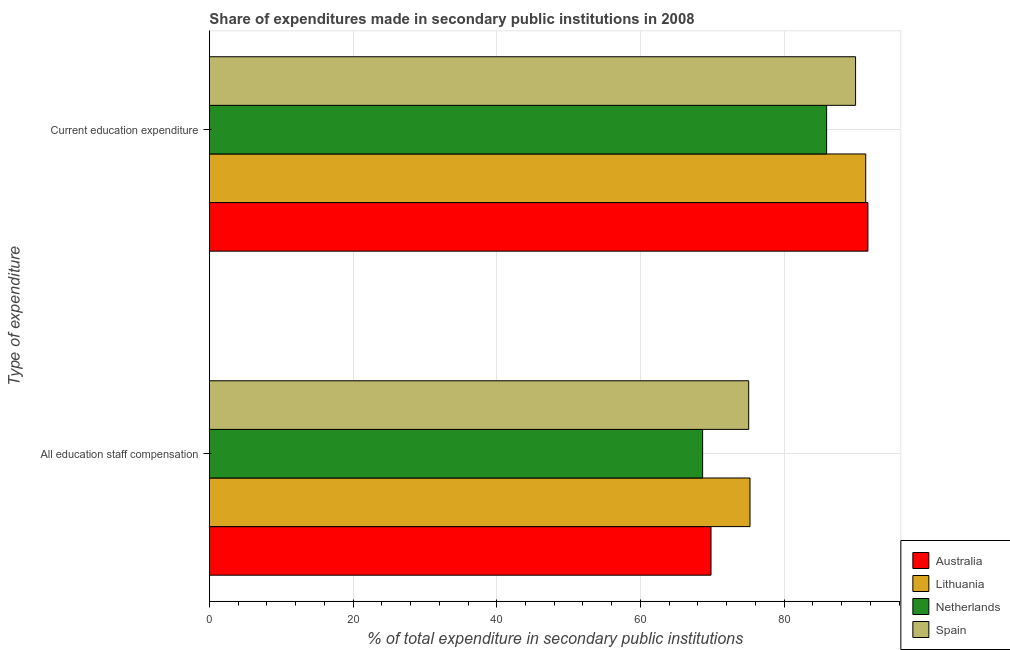Are the number of bars per tick equal to the number of legend labels?
Your answer should be very brief. Yes. How many bars are there on the 2nd tick from the top?
Give a very brief answer. 4. What is the label of the 1st group of bars from the top?
Provide a succinct answer. Current education expenditure. What is the expenditure in education in Lithuania?
Ensure brevity in your answer.  91.36. Across all countries, what is the maximum expenditure in staff compensation?
Provide a succinct answer. 75.25. Across all countries, what is the minimum expenditure in education?
Your answer should be compact. 85.92. In which country was the expenditure in staff compensation maximum?
Ensure brevity in your answer.  Lithuania. In which country was the expenditure in education minimum?
Give a very brief answer. Netherlands. What is the total expenditure in staff compensation in the graph?
Provide a succinct answer. 288.8. What is the difference between the expenditure in education in Spain and that in Lithuania?
Your response must be concise. -1.41. What is the difference between the expenditure in education in Lithuania and the expenditure in staff compensation in Australia?
Ensure brevity in your answer.  21.54. What is the average expenditure in education per country?
Ensure brevity in your answer.  89.72. What is the difference between the expenditure in education and expenditure in staff compensation in Netherlands?
Your answer should be very brief. 17.26. In how many countries, is the expenditure in staff compensation greater than 32 %?
Provide a short and direct response. 4. What is the ratio of the expenditure in education in Australia to that in Spain?
Provide a succinct answer. 1.02. What does the 1st bar from the top in Current education expenditure represents?
Give a very brief answer. Spain. What does the 2nd bar from the bottom in Current education expenditure represents?
Offer a very short reply. Lithuania. How many bars are there?
Provide a short and direct response. 8. Are all the bars in the graph horizontal?
Keep it short and to the point. Yes. How many countries are there in the graph?
Offer a terse response. 4. Are the values on the major ticks of X-axis written in scientific E-notation?
Your answer should be compact. No. Does the graph contain any zero values?
Your answer should be compact. No. Does the graph contain grids?
Your answer should be compact. Yes. Where does the legend appear in the graph?
Provide a succinct answer. Bottom right. How are the legend labels stacked?
Keep it short and to the point. Vertical. What is the title of the graph?
Keep it short and to the point. Share of expenditures made in secondary public institutions in 2008. What is the label or title of the X-axis?
Give a very brief answer. % of total expenditure in secondary public institutions. What is the label or title of the Y-axis?
Make the answer very short. Type of expenditure. What is the % of total expenditure in secondary public institutions in Australia in All education staff compensation?
Make the answer very short. 69.82. What is the % of total expenditure in secondary public institutions in Lithuania in All education staff compensation?
Give a very brief answer. 75.25. What is the % of total expenditure in secondary public institutions in Netherlands in All education staff compensation?
Offer a very short reply. 68.66. What is the % of total expenditure in secondary public institutions of Spain in All education staff compensation?
Offer a terse response. 75.07. What is the % of total expenditure in secondary public institutions of Australia in Current education expenditure?
Give a very brief answer. 91.66. What is the % of total expenditure in secondary public institutions of Lithuania in Current education expenditure?
Keep it short and to the point. 91.36. What is the % of total expenditure in secondary public institutions of Netherlands in Current education expenditure?
Keep it short and to the point. 85.92. What is the % of total expenditure in secondary public institutions in Spain in Current education expenditure?
Give a very brief answer. 89.95. Across all Type of expenditure, what is the maximum % of total expenditure in secondary public institutions in Australia?
Your answer should be compact. 91.66. Across all Type of expenditure, what is the maximum % of total expenditure in secondary public institutions of Lithuania?
Your response must be concise. 91.36. Across all Type of expenditure, what is the maximum % of total expenditure in secondary public institutions of Netherlands?
Give a very brief answer. 85.92. Across all Type of expenditure, what is the maximum % of total expenditure in secondary public institutions in Spain?
Your response must be concise. 89.95. Across all Type of expenditure, what is the minimum % of total expenditure in secondary public institutions in Australia?
Keep it short and to the point. 69.82. Across all Type of expenditure, what is the minimum % of total expenditure in secondary public institutions of Lithuania?
Provide a short and direct response. 75.25. Across all Type of expenditure, what is the minimum % of total expenditure in secondary public institutions of Netherlands?
Make the answer very short. 68.66. Across all Type of expenditure, what is the minimum % of total expenditure in secondary public institutions of Spain?
Offer a very short reply. 75.07. What is the total % of total expenditure in secondary public institutions of Australia in the graph?
Your answer should be very brief. 161.49. What is the total % of total expenditure in secondary public institutions of Lithuania in the graph?
Your response must be concise. 166.61. What is the total % of total expenditure in secondary public institutions in Netherlands in the graph?
Make the answer very short. 154.57. What is the total % of total expenditure in secondary public institutions in Spain in the graph?
Ensure brevity in your answer.  165.02. What is the difference between the % of total expenditure in secondary public institutions in Australia in All education staff compensation and that in Current education expenditure?
Ensure brevity in your answer.  -21.84. What is the difference between the % of total expenditure in secondary public institutions in Lithuania in All education staff compensation and that in Current education expenditure?
Provide a succinct answer. -16.11. What is the difference between the % of total expenditure in secondary public institutions of Netherlands in All education staff compensation and that in Current education expenditure?
Provide a short and direct response. -17.26. What is the difference between the % of total expenditure in secondary public institutions in Spain in All education staff compensation and that in Current education expenditure?
Make the answer very short. -14.88. What is the difference between the % of total expenditure in secondary public institutions of Australia in All education staff compensation and the % of total expenditure in secondary public institutions of Lithuania in Current education expenditure?
Your answer should be compact. -21.54. What is the difference between the % of total expenditure in secondary public institutions of Australia in All education staff compensation and the % of total expenditure in secondary public institutions of Netherlands in Current education expenditure?
Provide a short and direct response. -16.09. What is the difference between the % of total expenditure in secondary public institutions in Australia in All education staff compensation and the % of total expenditure in secondary public institutions in Spain in Current education expenditure?
Offer a very short reply. -20.12. What is the difference between the % of total expenditure in secondary public institutions in Lithuania in All education staff compensation and the % of total expenditure in secondary public institutions in Netherlands in Current education expenditure?
Your response must be concise. -10.67. What is the difference between the % of total expenditure in secondary public institutions in Lithuania in All education staff compensation and the % of total expenditure in secondary public institutions in Spain in Current education expenditure?
Provide a short and direct response. -14.7. What is the difference between the % of total expenditure in secondary public institutions of Netherlands in All education staff compensation and the % of total expenditure in secondary public institutions of Spain in Current education expenditure?
Provide a short and direct response. -21.29. What is the average % of total expenditure in secondary public institutions in Australia per Type of expenditure?
Offer a terse response. 80.74. What is the average % of total expenditure in secondary public institutions of Lithuania per Type of expenditure?
Your answer should be very brief. 83.31. What is the average % of total expenditure in secondary public institutions of Netherlands per Type of expenditure?
Provide a succinct answer. 77.29. What is the average % of total expenditure in secondary public institutions in Spain per Type of expenditure?
Offer a very short reply. 82.51. What is the difference between the % of total expenditure in secondary public institutions in Australia and % of total expenditure in secondary public institutions in Lithuania in All education staff compensation?
Offer a very short reply. -5.43. What is the difference between the % of total expenditure in secondary public institutions in Australia and % of total expenditure in secondary public institutions in Netherlands in All education staff compensation?
Offer a terse response. 1.17. What is the difference between the % of total expenditure in secondary public institutions of Australia and % of total expenditure in secondary public institutions of Spain in All education staff compensation?
Your response must be concise. -5.24. What is the difference between the % of total expenditure in secondary public institutions of Lithuania and % of total expenditure in secondary public institutions of Netherlands in All education staff compensation?
Offer a terse response. 6.59. What is the difference between the % of total expenditure in secondary public institutions in Lithuania and % of total expenditure in secondary public institutions in Spain in All education staff compensation?
Offer a very short reply. 0.18. What is the difference between the % of total expenditure in secondary public institutions of Netherlands and % of total expenditure in secondary public institutions of Spain in All education staff compensation?
Provide a succinct answer. -6.41. What is the difference between the % of total expenditure in secondary public institutions in Australia and % of total expenditure in secondary public institutions in Lithuania in Current education expenditure?
Keep it short and to the point. 0.3. What is the difference between the % of total expenditure in secondary public institutions of Australia and % of total expenditure in secondary public institutions of Netherlands in Current education expenditure?
Your answer should be compact. 5.75. What is the difference between the % of total expenditure in secondary public institutions in Australia and % of total expenditure in secondary public institutions in Spain in Current education expenditure?
Keep it short and to the point. 1.72. What is the difference between the % of total expenditure in secondary public institutions in Lithuania and % of total expenditure in secondary public institutions in Netherlands in Current education expenditure?
Give a very brief answer. 5.44. What is the difference between the % of total expenditure in secondary public institutions of Lithuania and % of total expenditure in secondary public institutions of Spain in Current education expenditure?
Your response must be concise. 1.41. What is the difference between the % of total expenditure in secondary public institutions of Netherlands and % of total expenditure in secondary public institutions of Spain in Current education expenditure?
Ensure brevity in your answer.  -4.03. What is the ratio of the % of total expenditure in secondary public institutions in Australia in All education staff compensation to that in Current education expenditure?
Ensure brevity in your answer.  0.76. What is the ratio of the % of total expenditure in secondary public institutions in Lithuania in All education staff compensation to that in Current education expenditure?
Your answer should be compact. 0.82. What is the ratio of the % of total expenditure in secondary public institutions of Netherlands in All education staff compensation to that in Current education expenditure?
Keep it short and to the point. 0.8. What is the ratio of the % of total expenditure in secondary public institutions of Spain in All education staff compensation to that in Current education expenditure?
Ensure brevity in your answer.  0.83. What is the difference between the highest and the second highest % of total expenditure in secondary public institutions in Australia?
Keep it short and to the point. 21.84. What is the difference between the highest and the second highest % of total expenditure in secondary public institutions in Lithuania?
Provide a succinct answer. 16.11. What is the difference between the highest and the second highest % of total expenditure in secondary public institutions of Netherlands?
Make the answer very short. 17.26. What is the difference between the highest and the second highest % of total expenditure in secondary public institutions in Spain?
Give a very brief answer. 14.88. What is the difference between the highest and the lowest % of total expenditure in secondary public institutions in Australia?
Ensure brevity in your answer.  21.84. What is the difference between the highest and the lowest % of total expenditure in secondary public institutions in Lithuania?
Your response must be concise. 16.11. What is the difference between the highest and the lowest % of total expenditure in secondary public institutions in Netherlands?
Ensure brevity in your answer.  17.26. What is the difference between the highest and the lowest % of total expenditure in secondary public institutions of Spain?
Your answer should be very brief. 14.88. 